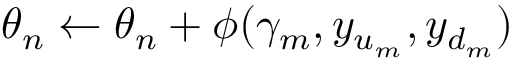Convert formula to latex. <formula><loc_0><loc_0><loc_500><loc_500>\theta _ { n } \gets \theta _ { n } + \phi ( \gamma _ { m } , y _ { u _ { m } } , y _ { d _ { m } } )</formula> 